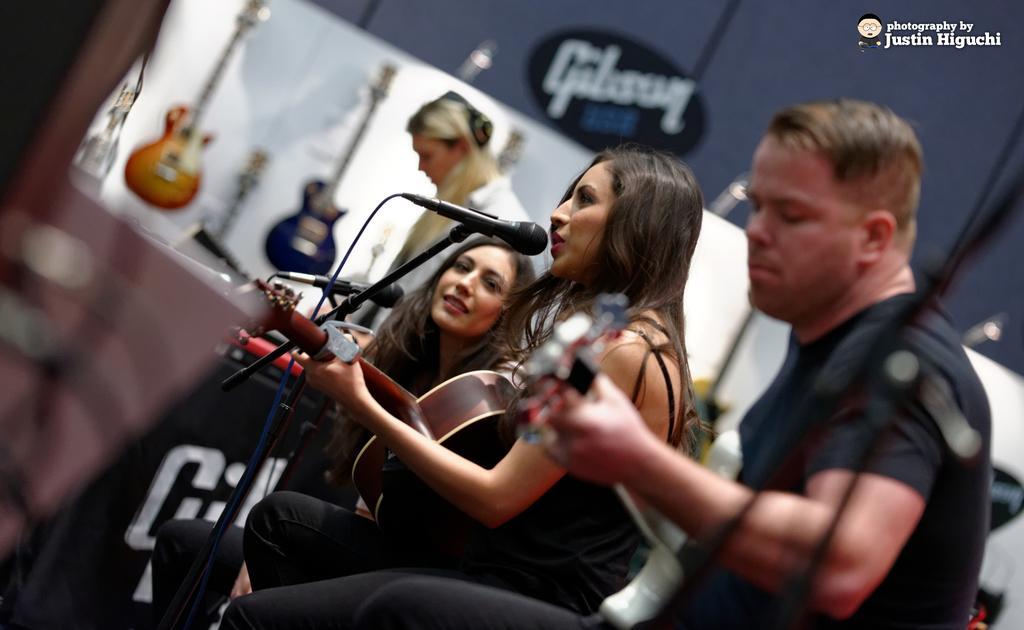In one or two sentences, can you explain what this image depicts? There is a woman sitting at the center. She is holding a guitar in her hand and she is singing on a microphone. There is another woman sitting beside to her and she is smiling. There is a man who is sitting right side. 